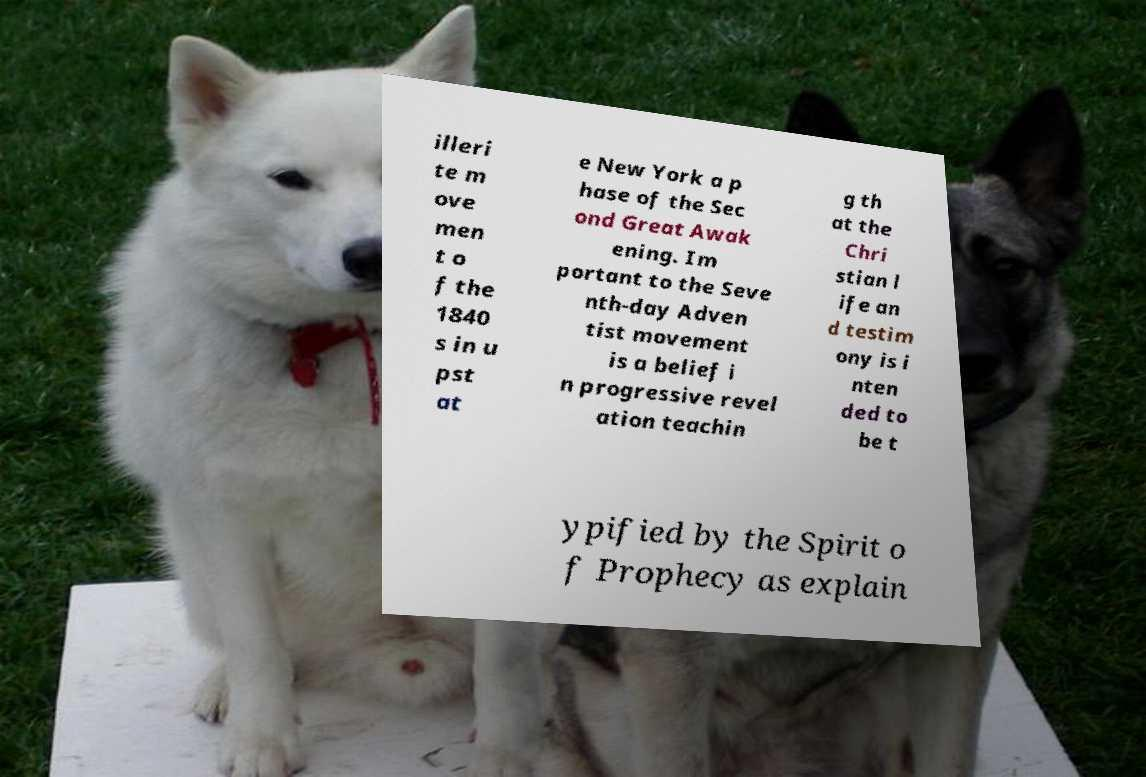Please read and relay the text visible in this image. What does it say? illeri te m ove men t o f the 1840 s in u pst at e New York a p hase of the Sec ond Great Awak ening. Im portant to the Seve nth-day Adven tist movement is a belief i n progressive revel ation teachin g th at the Chri stian l ife an d testim ony is i nten ded to be t ypified by the Spirit o f Prophecy as explain 